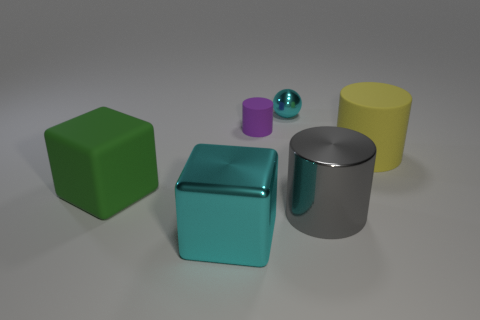Are there any objects with matte surfaces? Yes, the two objects with matte surfaces are the yellow cylinder and the green cube. Do these objects share any similarities in shape or size? While their surfaces have a similar non-reflective finish, they differ in shape, one being a cube and the other a cylinder. They are both relatively similar in size compared to the other objects in the scene. 